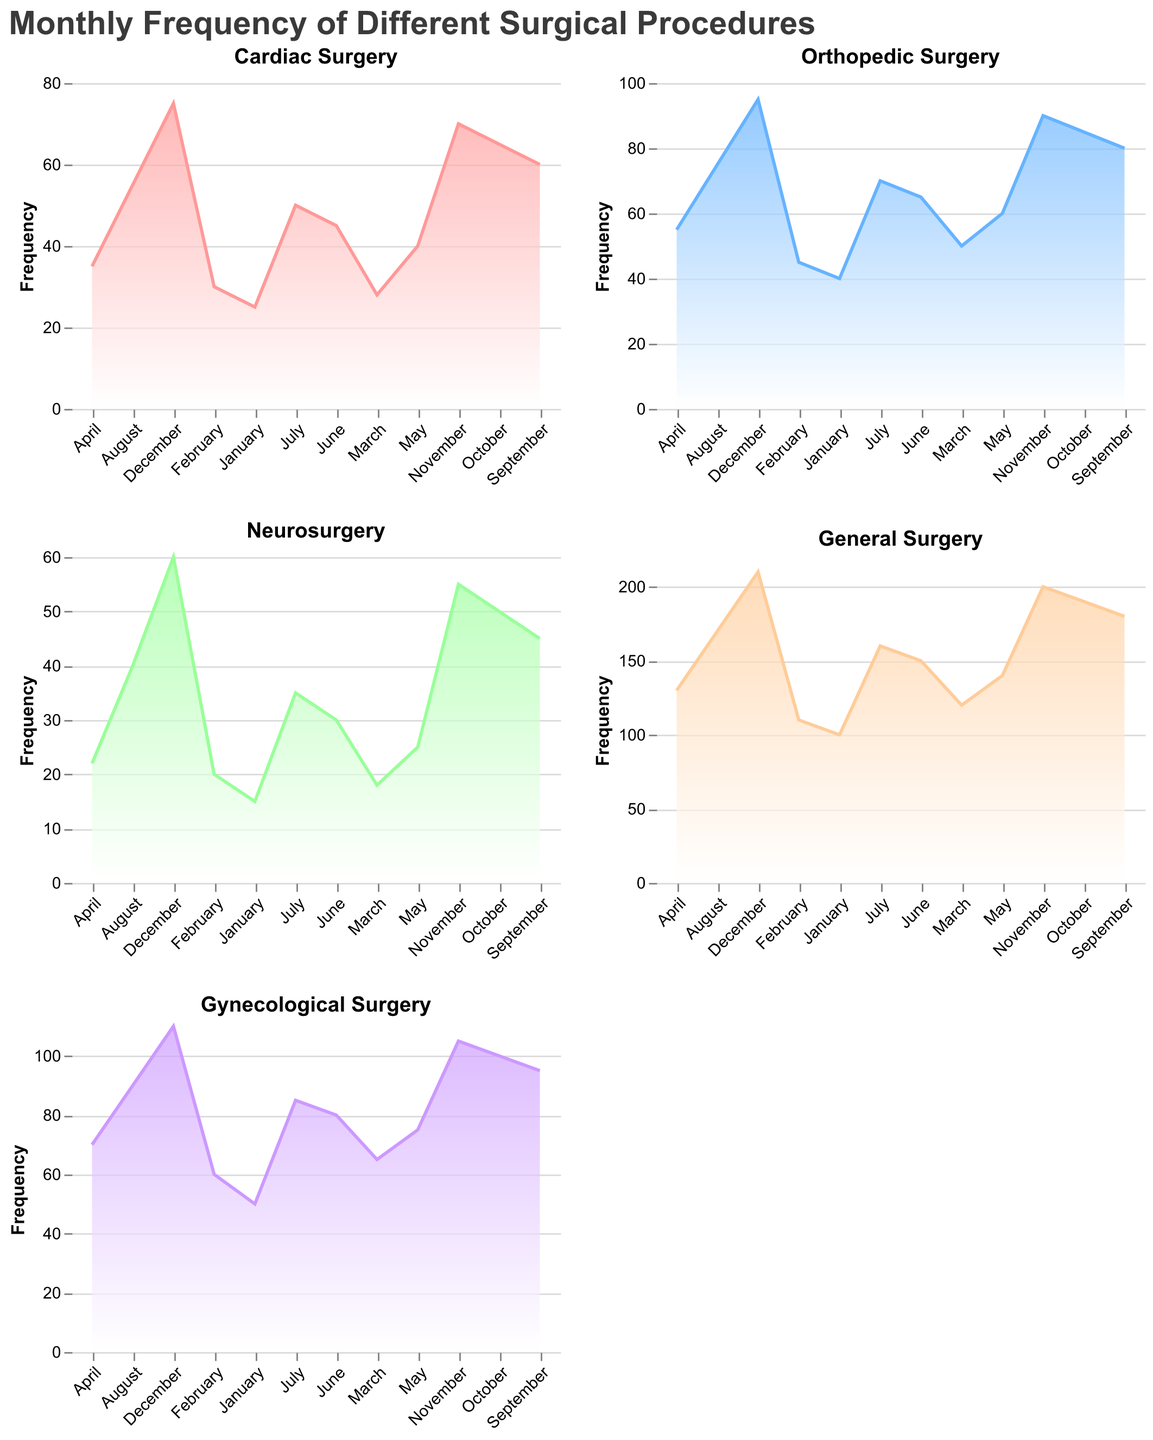How does the frequency of Cardiac Surgery change over the months? The area chart representing Cardiac Surgery shows that the frequency starts at 25 in January and increases steadily each month, reaching 75 in December.
Answer: Increases from January to December What month has the highest frequency for Neurosurgery? By examining the Neurosurgery area chart, we can see that December has the highest frequency at 60.
Answer: December Compare the frequency of General Surgery and Gynecological Surgery in June. Which one is higher? The General Surgery chart shows a frequency of 150 in June, while the Gynecological Surgery chart shows a frequency of 80. Therefore, General Surgery is higher in June.
Answer: General Surgery Which month shows the largest increase in frequency for Orthopedic Surgery compared to the previous month? Comparing the frequency values in the Orthopedic Surgery area chart month by month, the largest increase is from September to October, where the frequency increases from 80 to 85.
Answer: October Calculate the average frequency of Gynecological Surgery throughout the year. The sum of frequencies for Gynecological Surgery from January to December is (50 + 60 + 65 + 70 + 75 + 80 + 85 + 90 + 95 + 100 + 105 + 110) = 985. The average frequency is 985/12 = 82.08
Answer: 82.08 What is the combined frequency of Cardiac Surgery and Orthopedic Surgery in March? The frequency of Cardiac Surgery in March is 28 and Orthopedic Surgery is 50. Their combined frequency is 28 + 50 = 78.
Answer: 78 During which season (Winter, Spring, Summer, Fall) is General Surgery performed most frequently? General Surgery frequencies are highest in September, October, November, and December, which are in Fall and early Winter. But the highest frequency (210) is in December. December is considered Winter.
Answer: Winter Compare the trends of Cardiac Surgery and Neurosurgery across the year. Do they follow similar patterns? The trend lines for both Cardiac Surgery and Neurosurgery show a continuous increase from January to December, but Cardiac Surgery starts and ends at higher frequencies.
Answer: Yes, similar patterns but different frequencies By how much does the frequency of Gynecological Surgery increase from January to December? The frequency of Gynecological Surgery in January is 50 and in December is 110. The increase is 110 - 50 = 60.
Answer: 60 